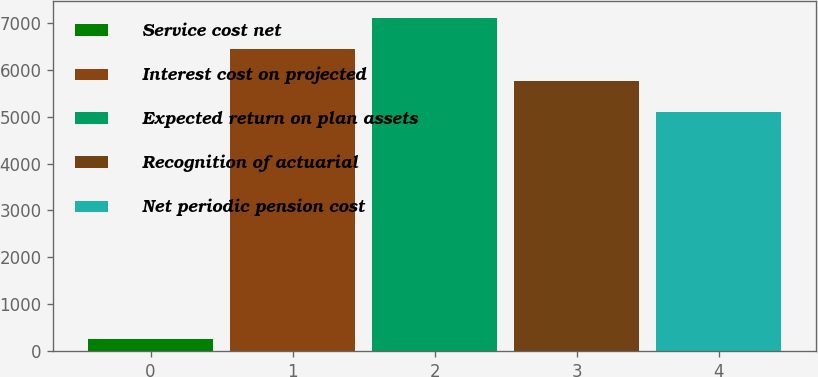<chart> <loc_0><loc_0><loc_500><loc_500><bar_chart><fcel>Service cost net<fcel>Interest cost on projected<fcel>Expected return on plan assets<fcel>Recognition of actuarial<fcel>Net periodic pension cost<nl><fcel>264<fcel>6439<fcel>7103.2<fcel>5758.2<fcel>5094<nl></chart> 